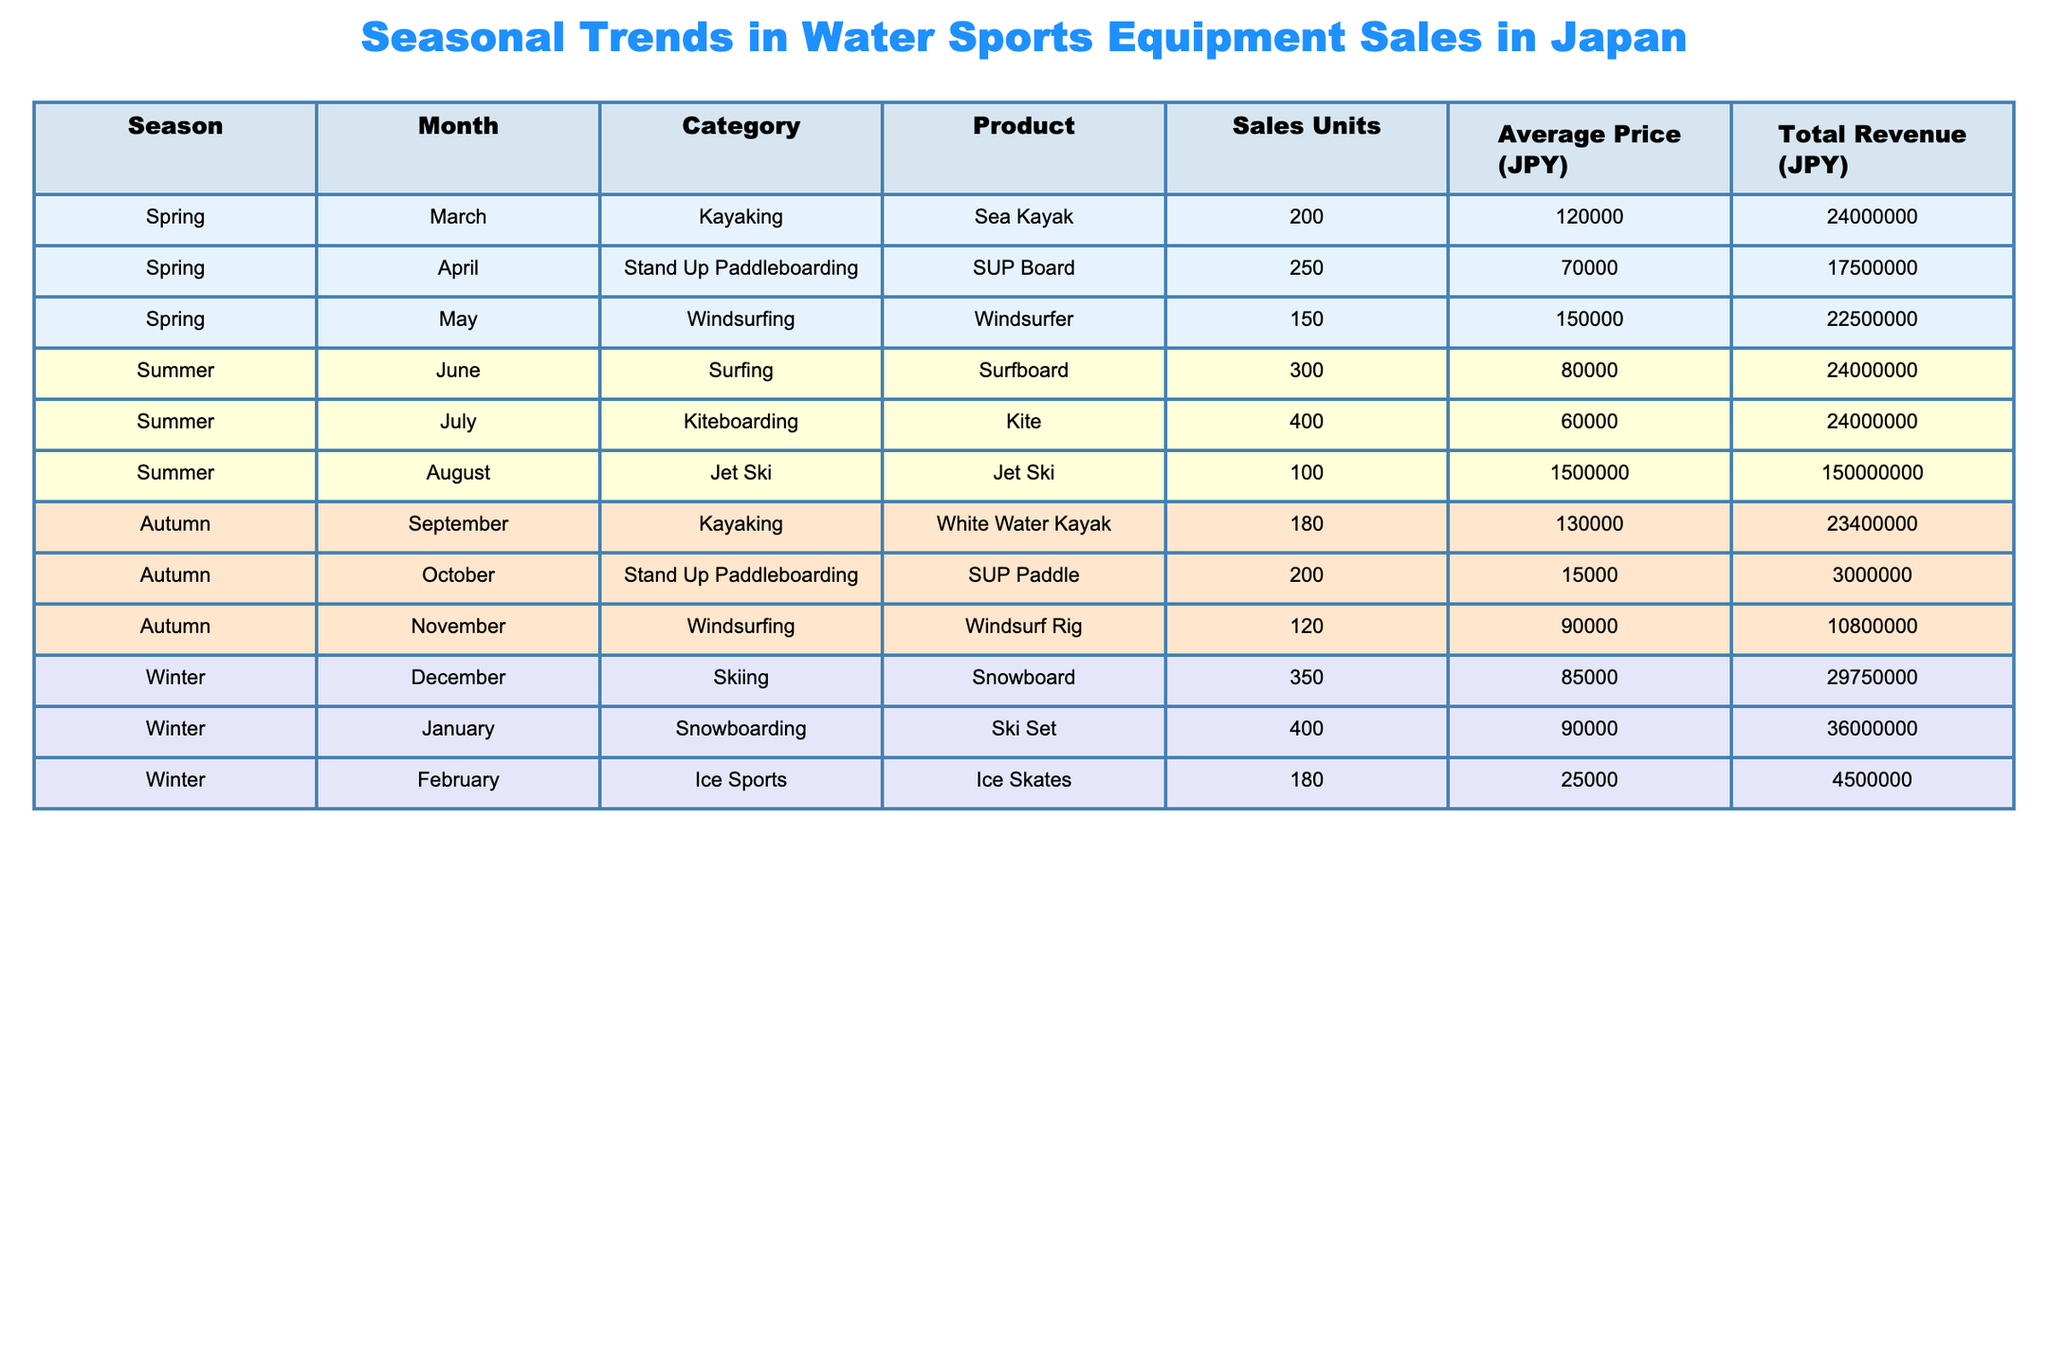What is the total revenue generated from Jet Ski sales in August? The table shows that in August, there were 100 Jet Skis sold at an average price of JPY 1,500,000. Therefore, the total revenue is calculated as 100 * 1,500,000 = 150,000,000 JPY.
Answer: 150,000,000 JPY How many units of Stand Up Paddleboarding equipment were sold in Spring? The Spring season has two entries for Stand Up Paddleboarding: one for March with 0 units sold (not present in table) and another for April with 250 units, yielding a total of 250 units sold in Spring.
Answer: 250 units Which month had the highest sales units for Kiteboarding equipment? The table lists Kiteboarding sales for July with 400 units. No other months even list Kiteboarding products, confirming July had the highest sales.
Answer: July What is the average price of the products sold in Autumn? For Autumn, we have Sales Units and Average Prices as follows: September (180 units, JPY 130,000), October (200 units, JPY 15,000), November (120 units, JPY 90,000). The total revenue can be computed (180*130,000 + 200*15,000 + 120*90,000) = 23,400,000 + 3,000,000 + 10,800,000 = 37,200,000 JPY and the total units sold is 180 + 200 + 120 = 500. Thus, the average price = Total Revenue / Total Units = 37,200,000 / 500 = JPY 74,400.
Answer: JPY 74,400 Is there any water sports category that saw higher sales in Winter than in Summer? Analyzing the sales for Winter: Snowboard (350 units), Ski Set (400 units), Ice Skates (180 units) totals 930 units. In Summer: Surfboard (300 units), Kite (400 units), Jet Ski (100 units) totals 800 units. Since 930 > 800, Winter saw higher sales in total.
Answer: Yes What is the difference in total revenue between Spring and Summer? Total revenue from Spring: 24,000,000 (March) + 17,500,000 (April) + 22,500,000 (May) = 64,000,000 JPY; Total revenue from Summer: 24,000,000 (June) + 24,000,000 (July) + 150,000,000 (August) = 198,000,000 JPY. The difference = 198,000,000 - 64,000,000 = 134,000,000 JPY.
Answer: 134,000,000 JPY Which product category had the least sales in November? The table shows in November, 120 units of Windsurfing equipment were sold, which is the only entry for that month; hence it had the least sales.
Answer: Windsurfing Which season had the lowest variety of products sold? In Spring, only three unique types of products (Sea Kayak, SUP Board, Windsurfer) were sold versus four in other seasons (Summer and Winter), so Spring had the lowest variety of products.
Answer: Spring 